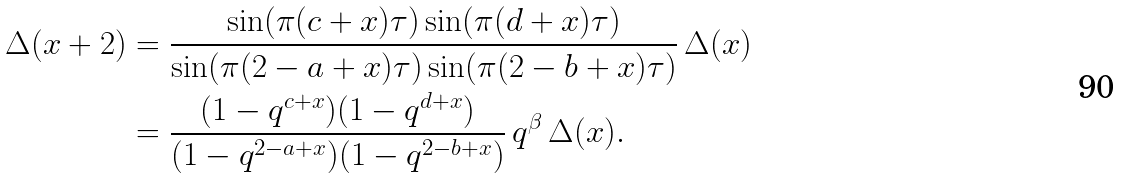<formula> <loc_0><loc_0><loc_500><loc_500>\Delta ( x + 2 ) & = \frac { \sin ( \pi ( c + x ) \tau ) \sin ( \pi ( d + x ) \tau ) } { \sin ( \pi ( 2 - a + x ) \tau ) \sin ( \pi ( 2 - b + x ) \tau ) } \, \Delta ( x ) \\ & = \frac { ( 1 - q ^ { c + x } ) ( 1 - q ^ { d + x } ) } { ( 1 - q ^ { 2 - a + x } ) ( 1 - q ^ { 2 - b + x } ) } \, q ^ { \beta } \, \Delta ( x ) .</formula> 